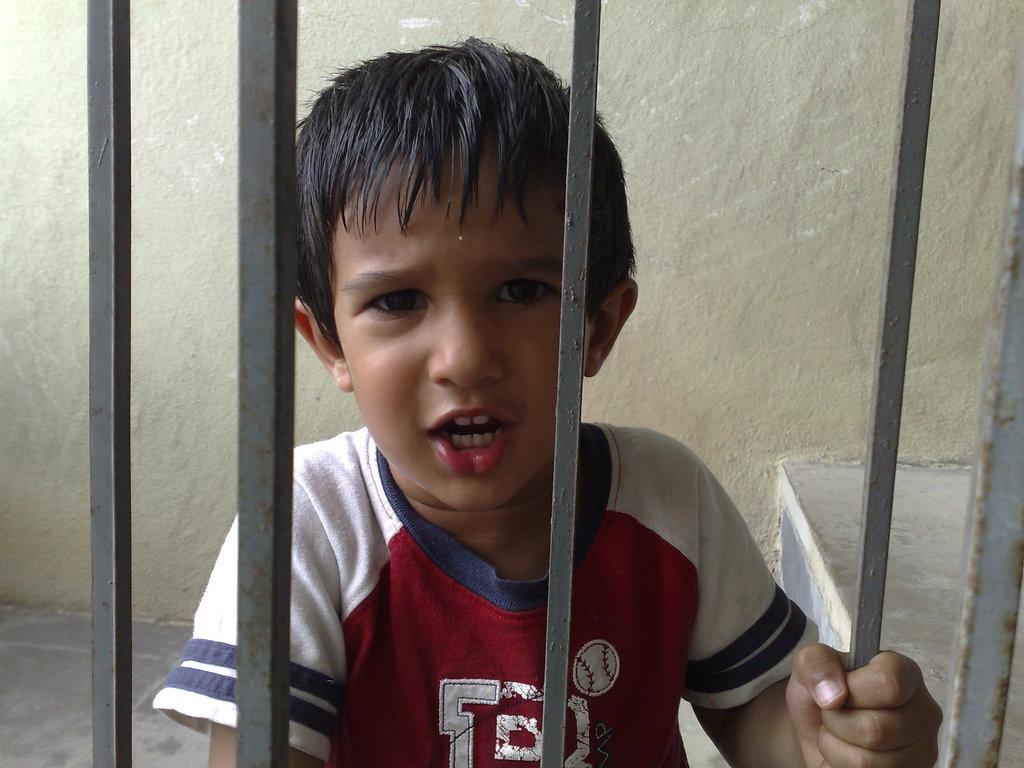Describe this image in one or two sentences. In this image there is a boy behind the metal rods. Behind him there is a wall. 